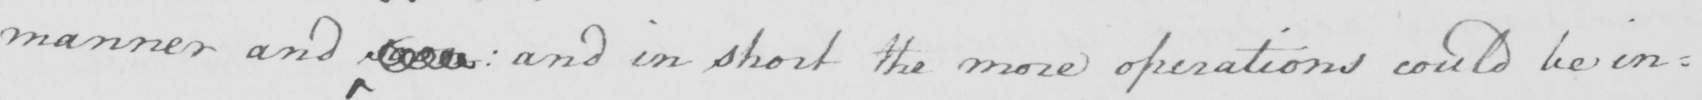Can you read and transcribe this handwriting? manner and soon  :  and in short the more operations could be in= 